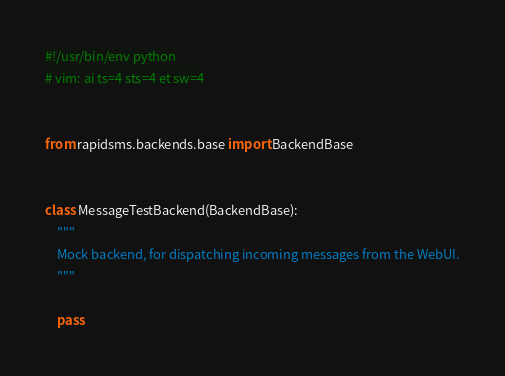<code> <loc_0><loc_0><loc_500><loc_500><_Python_>#!/usr/bin/env python
# vim: ai ts=4 sts=4 et sw=4


from rapidsms.backends.base import BackendBase


class MessageTestBackend(BackendBase):
    """
    Mock backend, for dispatching incoming messages from the WebUI.
    """

    pass
</code> 